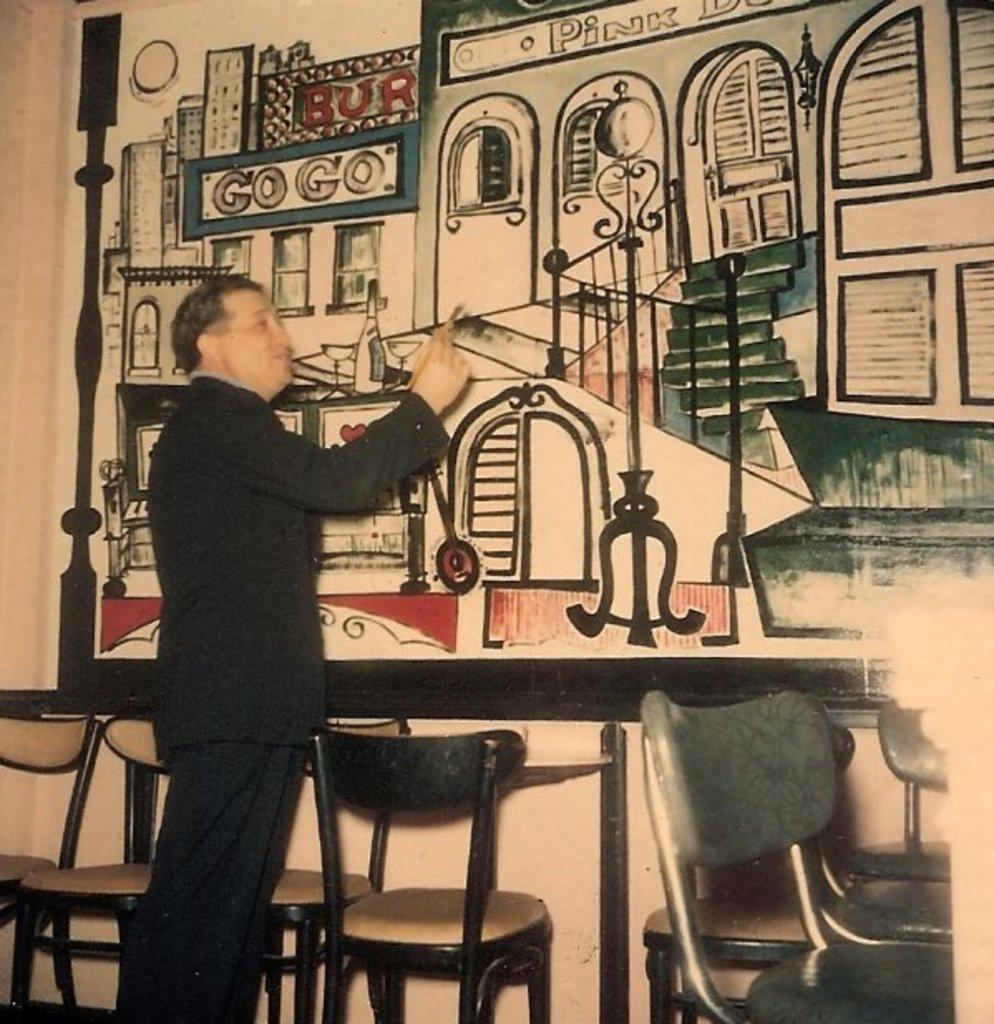What is the person in the image doing? The person is standing in the image and holding a pen. What can be seen in the background of the image? There is graffiti and empty chairs in the background of the image. What type of frogs can be seen jumping on the coal in the image? There are no frogs or coal present in the image. How does the person pull the chairs in the image? The person is not pulling any chairs in the image; they are simply standing and holding a pen. 